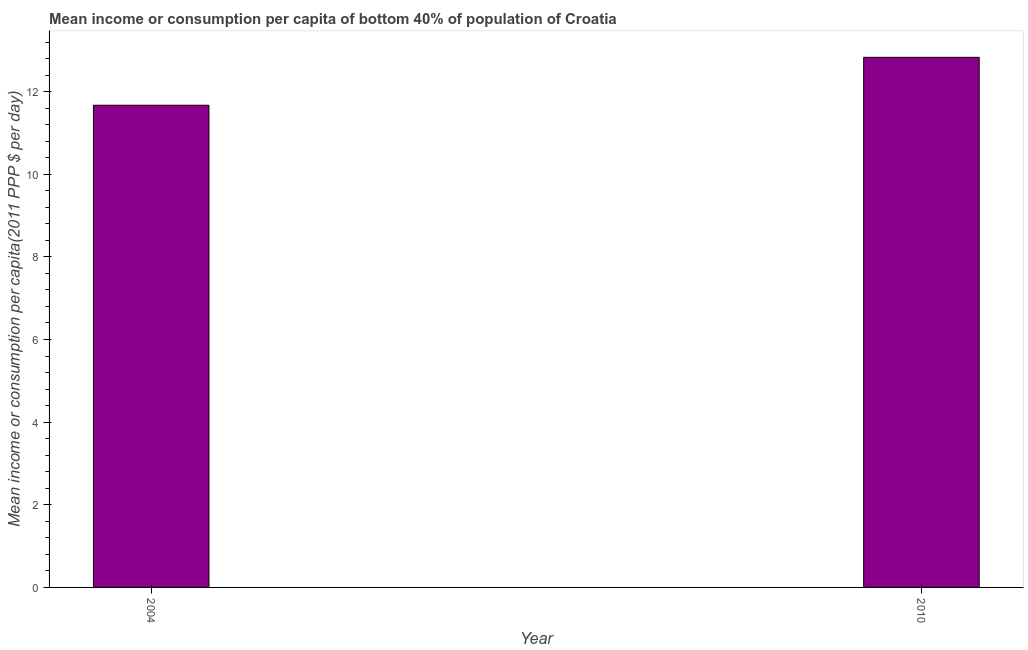Does the graph contain grids?
Ensure brevity in your answer.  No. What is the title of the graph?
Your answer should be compact. Mean income or consumption per capita of bottom 40% of population of Croatia. What is the label or title of the X-axis?
Provide a succinct answer. Year. What is the label or title of the Y-axis?
Ensure brevity in your answer.  Mean income or consumption per capita(2011 PPP $ per day). What is the mean income or consumption in 2010?
Offer a terse response. 12.83. Across all years, what is the maximum mean income or consumption?
Offer a very short reply. 12.83. Across all years, what is the minimum mean income or consumption?
Offer a terse response. 11.67. In which year was the mean income or consumption maximum?
Provide a succinct answer. 2010. What is the difference between the mean income or consumption in 2004 and 2010?
Make the answer very short. -1.16. What is the average mean income or consumption per year?
Your response must be concise. 12.25. What is the median mean income or consumption?
Your answer should be compact. 12.25. In how many years, is the mean income or consumption greater than 8.4 $?
Your response must be concise. 2. What is the ratio of the mean income or consumption in 2004 to that in 2010?
Offer a terse response. 0.91. In how many years, is the mean income or consumption greater than the average mean income or consumption taken over all years?
Keep it short and to the point. 1. How many bars are there?
Give a very brief answer. 2. Are all the bars in the graph horizontal?
Ensure brevity in your answer.  No. What is the Mean income or consumption per capita(2011 PPP $ per day) in 2004?
Provide a short and direct response. 11.67. What is the Mean income or consumption per capita(2011 PPP $ per day) in 2010?
Make the answer very short. 12.83. What is the difference between the Mean income or consumption per capita(2011 PPP $ per day) in 2004 and 2010?
Your answer should be very brief. -1.16. What is the ratio of the Mean income or consumption per capita(2011 PPP $ per day) in 2004 to that in 2010?
Keep it short and to the point. 0.91. 